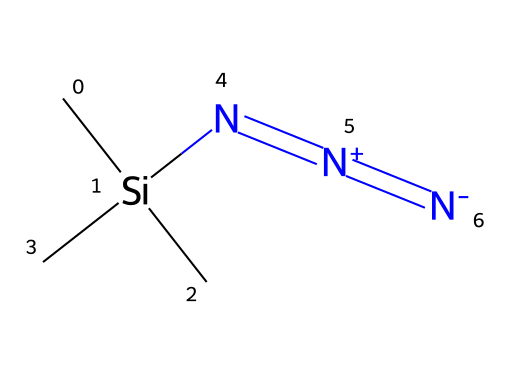What is the main functional group present in trimethylsilyl azide? The main functional group in trimethylsilyl azide is azide, characterized by the presence of three nitrogen atoms linked in a specific manner (N3) as seen in the structure.
Answer: azide How many silicon atoms are in trimethylsilyl azide? Analyzing the structure shows that there is one silicon atom connected to three methyl groups, which is evident in the provided SMILES representation.
Answer: one What is the ratio of nitrogen atoms to carbon atoms in trimethylsilyl azide? From the chemical structure, there are three nitrogen atoms and three carbon atoms (from the three methyl groups), making the ratio 3:3.
Answer: 1:1 What type of bond connects the nitrogen atoms in the azide group? The nitrogen atoms in the azide group are connected by double bonds, as indicated by the "=" signs in the structure.
Answer: double bonds What role does trimethylsilyl azide typically serve in click chemistry? Trimethylsilyl azide is commonly used as a source of azide groups for click reactions, facilitating the formation of triazoles in organic synthesis.
Answer: azide source What is the total number of atoms in trimethylsilyl azide? Counting the atoms from the chemical structure, we find 6 hydrogen, 3 carbon, 1 silicon, and 3 nitrogen atoms, totaling 13 atoms.
Answer: 13 